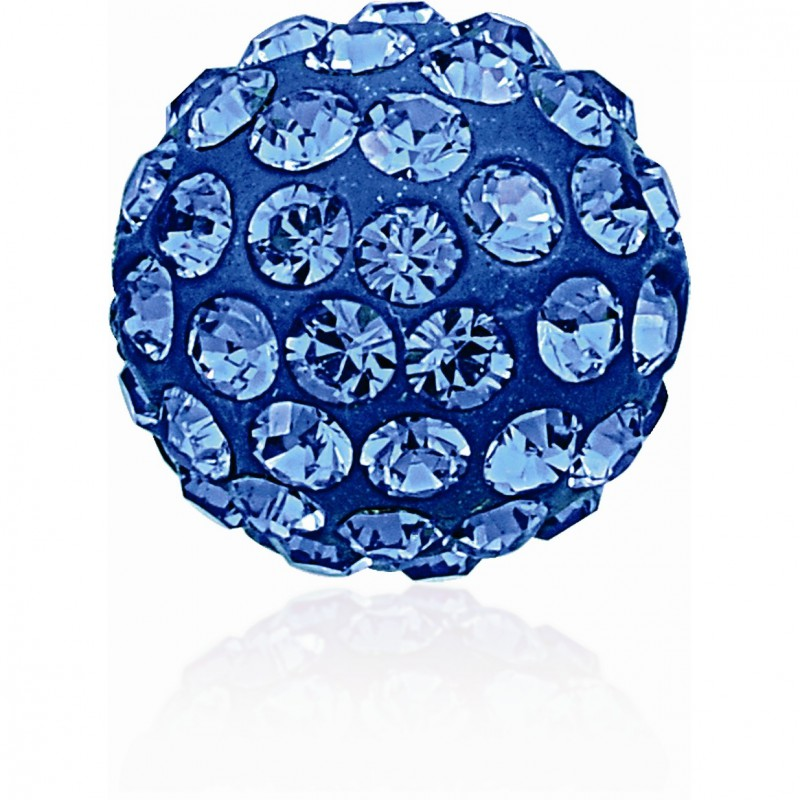What would you imagine if these gemstones were part of a larger art piece? If these gemstones were part of a larger art piece, it could be an intricate mosaic depicting a serene underwater scene. Imagine these blue gemstones representing the shimmering scales of a magnificent, mythical sea creature gliding through a coral reef. The different sized gems could be used to create a sense of movement and texture, beautifully illustrating the fluidity and grace of the creature’s form. The varying depths of the gem placements could mimic the play of sunlight filtering through the water, casting sparkling reflections and adding dynamic light effects to the piece. Could you extend the art piece's theme further? Absolutely! Extending the theme, the art piece could expand to a grand mural featuring an entire marine ecosystem. The blue gemstones would be just one part of the intricate scene. Around the sea creature, smaller, equally enchanting seaweeds and corals could be represented by gemstones of different colors and shades, each carefully chosen to mimic the natural hues of underwater flora. Pearls and mother-of-pearl pieces could be used to create luminescent bubbles rising to the surface, adding a realistic touch to the oceanic backdrop. The entire scene could be framed by intricate golden accents mimicking sunlight penetrating the water’s surface, creating a mesmerizing blend of natural beauty and artistic craftsmanship. This mural would not only celebrate the splendor of the ocean but also the exquisite detail and creativity that gemstones can bring to art. 